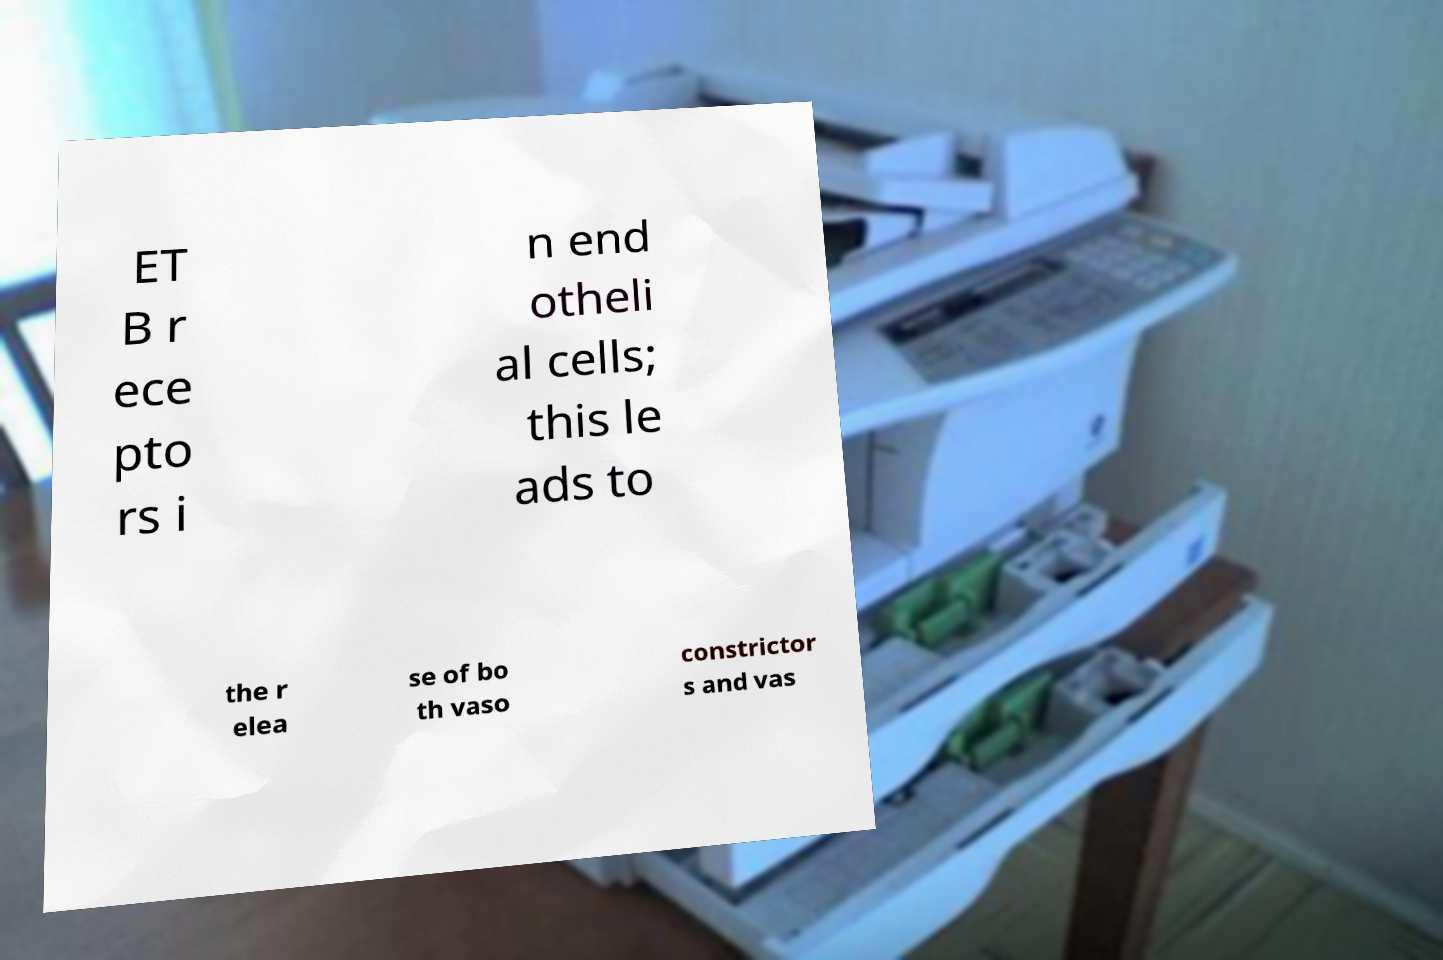Please identify and transcribe the text found in this image. ET B r ece pto rs i n end otheli al cells; this le ads to the r elea se of bo th vaso constrictor s and vas 